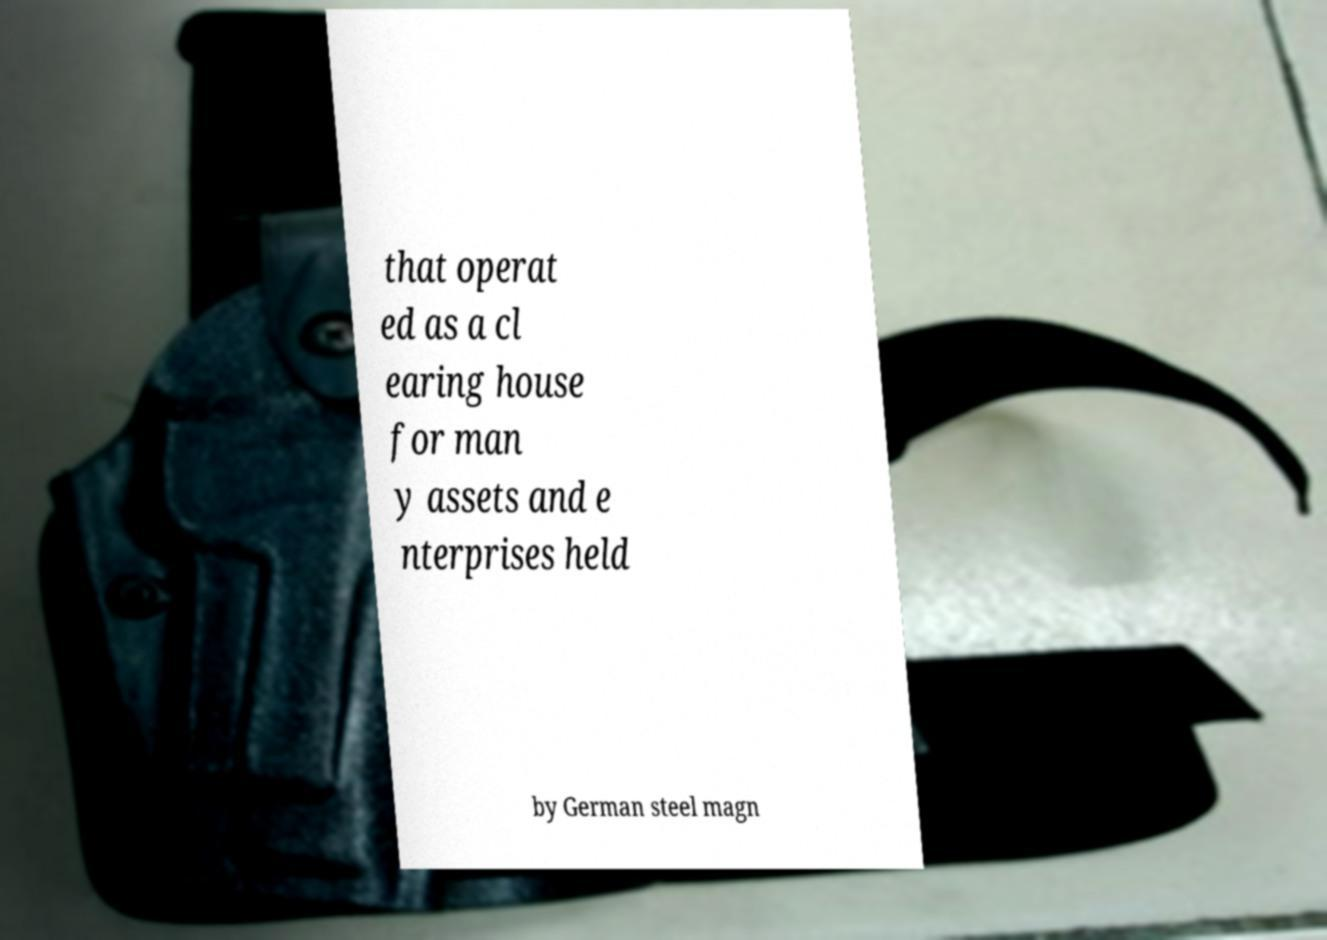Can you read and provide the text displayed in the image?This photo seems to have some interesting text. Can you extract and type it out for me? that operat ed as a cl earing house for man y assets and e nterprises held by German steel magn 